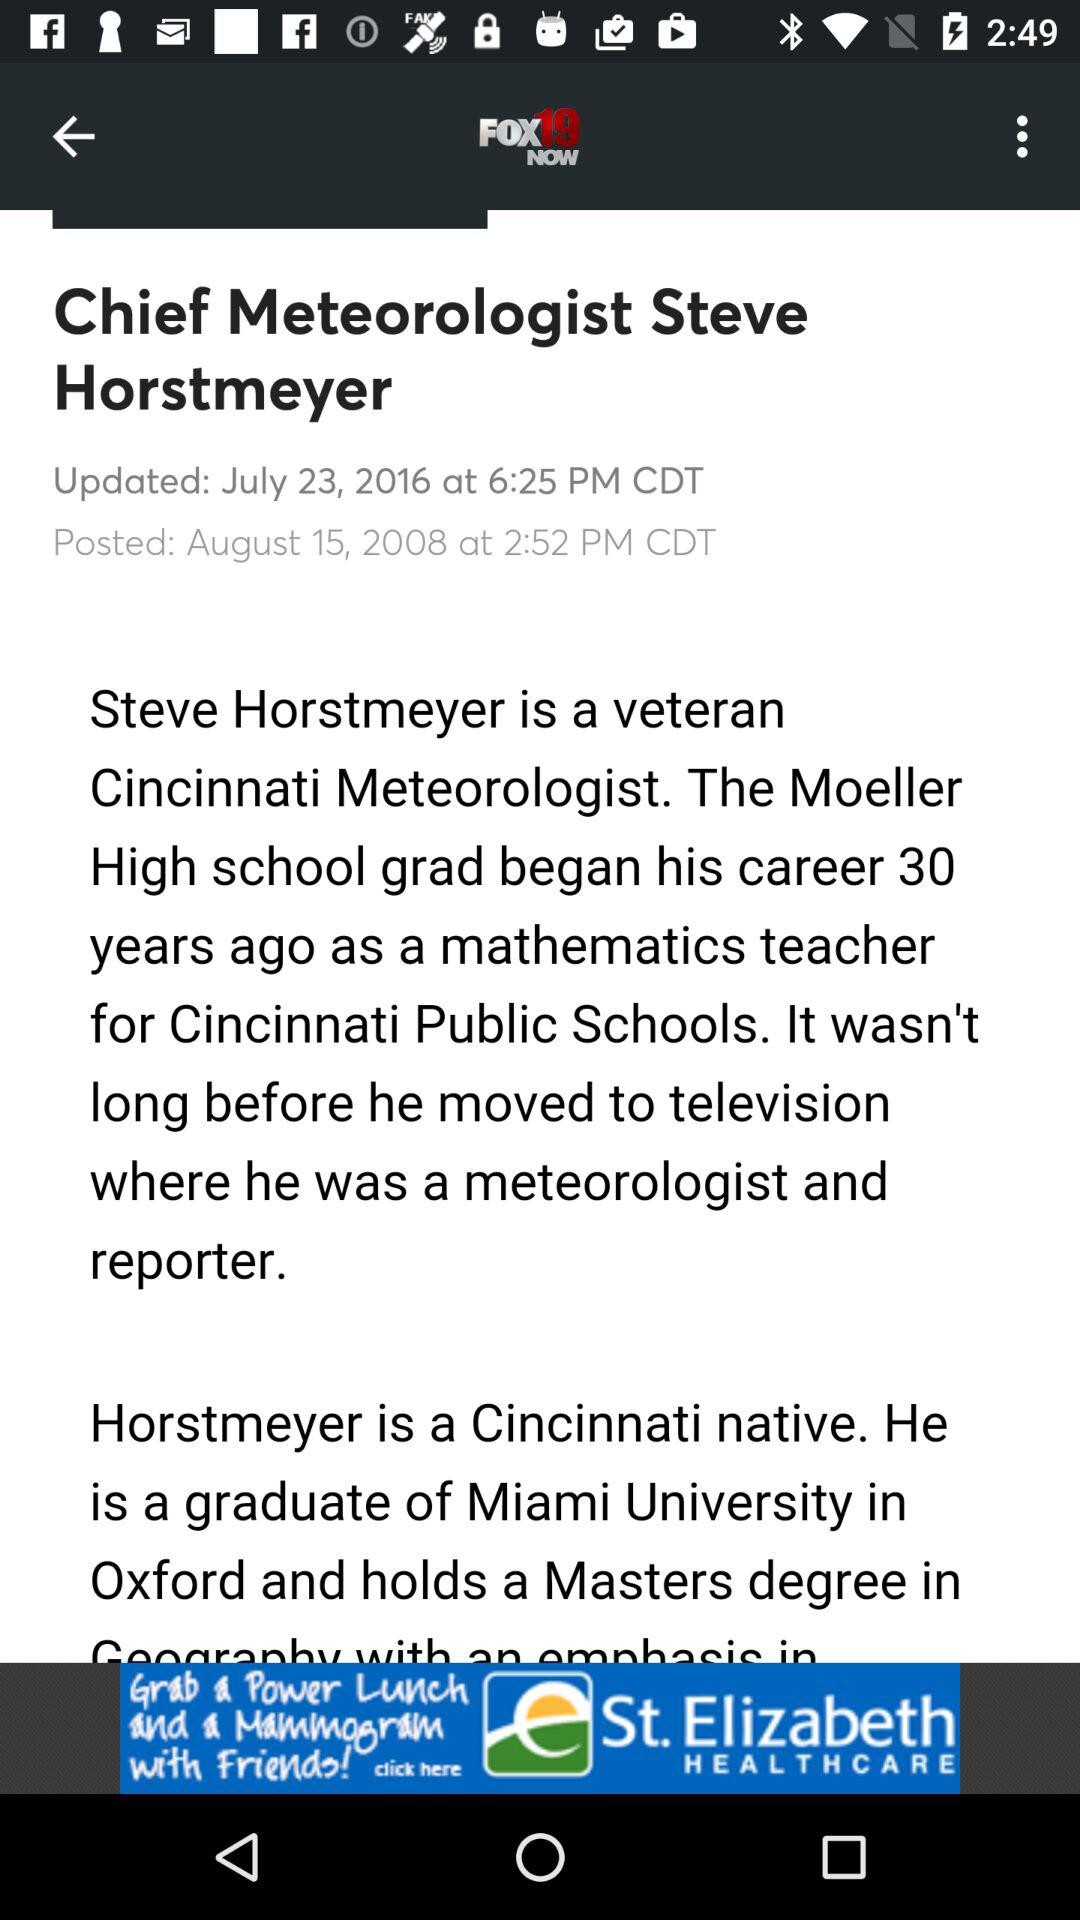What are the news headlines? The news headline is "Chief Meteorologist Steve Horstmeyer". 